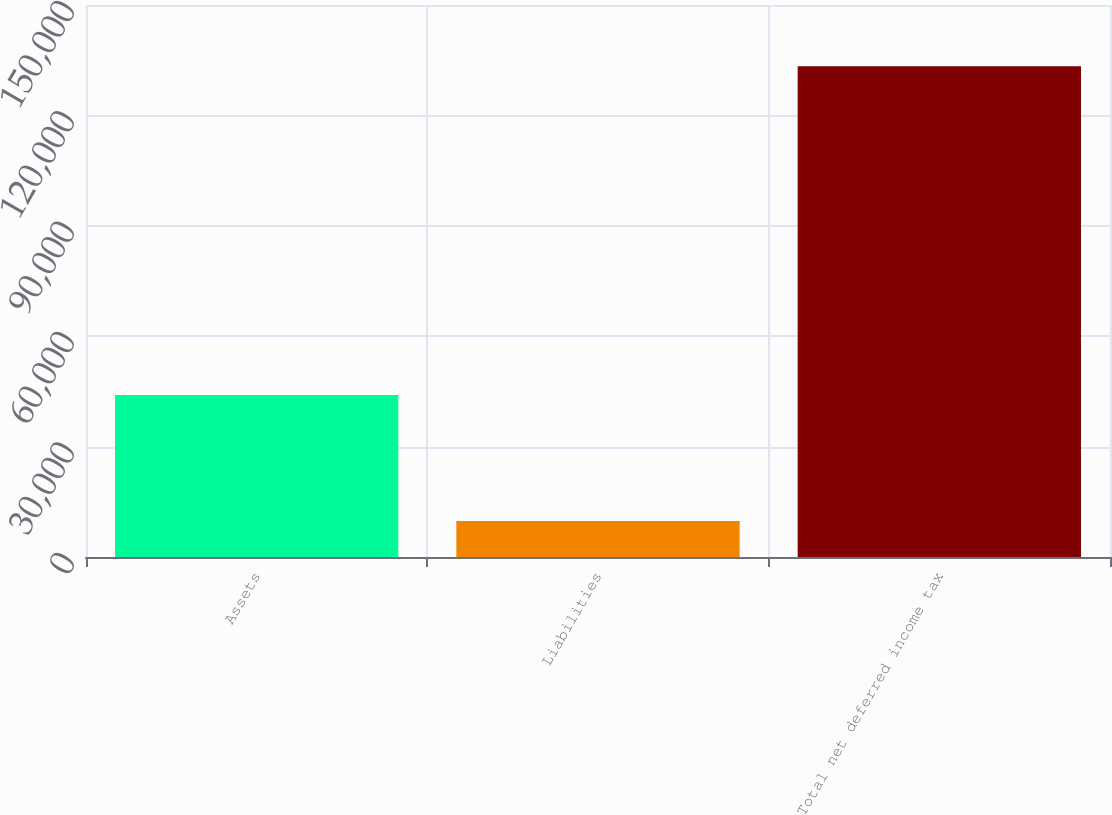Convert chart to OTSL. <chart><loc_0><loc_0><loc_500><loc_500><bar_chart><fcel>Assets<fcel>Liabilities<fcel>Total net deferred income tax<nl><fcel>44042<fcel>9804<fcel>133337<nl></chart> 